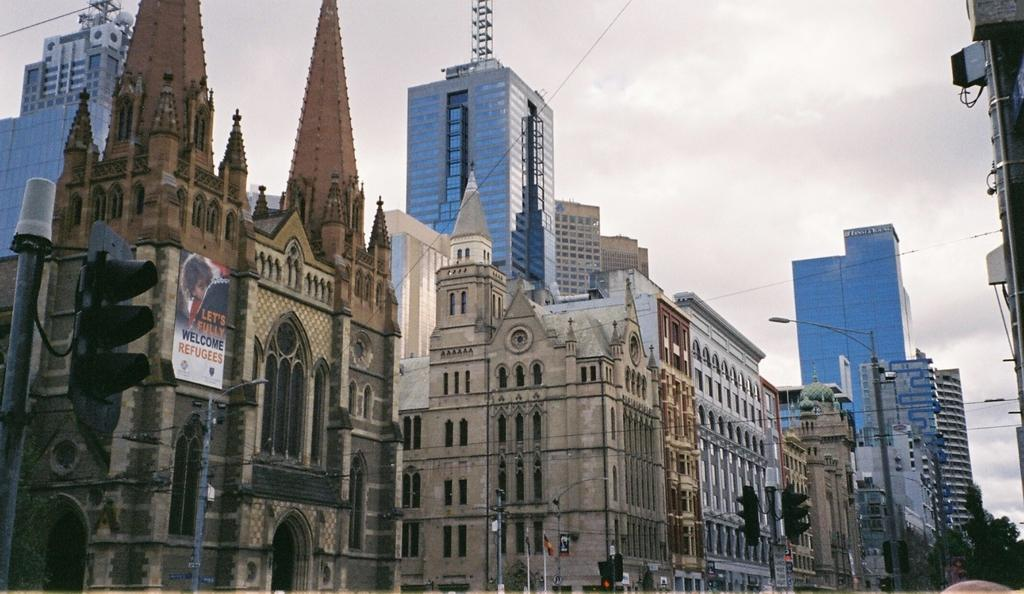What type of structures can be seen in the image? There are buildings in the image. What architectural features are visible on the buildings? There are windows in the image. What other objects can be seen in the image? There are wires, light poles, trees, and boards in the image. What is visible in the background of the image? The sky is visible in the image. Can you determine the time of day the image was taken? The image is likely taken during the day, as the sky is visible. What type of notebook is being used to record history in the image? There is no notebook or history recording activity present in the image. What type of pot is being used to cook food in the image? There is no pot or cooking activity present in the image. 